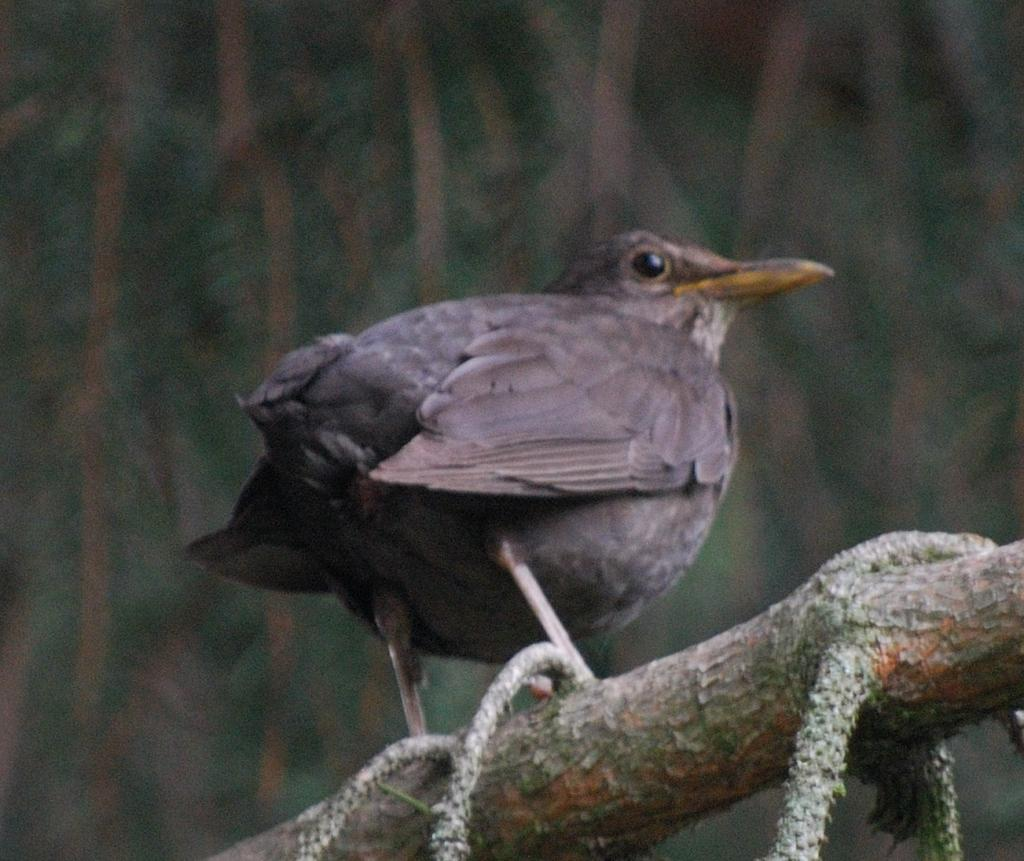What type of animal is in the image? There is a bird in the image. Can you describe the bird's coloring? The bird has brown, black, and yellow coloring. Where is the bird located in the image? The bird is on a tree branch. What can be seen in the background of the image? There are trees in the background of the image. What type of fruit is the bird holding in its arm in the image? There is no fruit or arm present in the image; the bird is simply perched on a tree branch. 